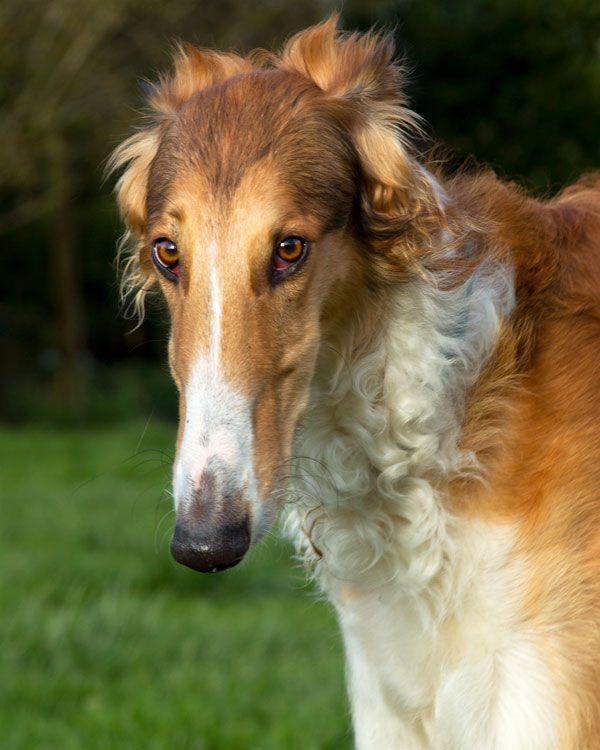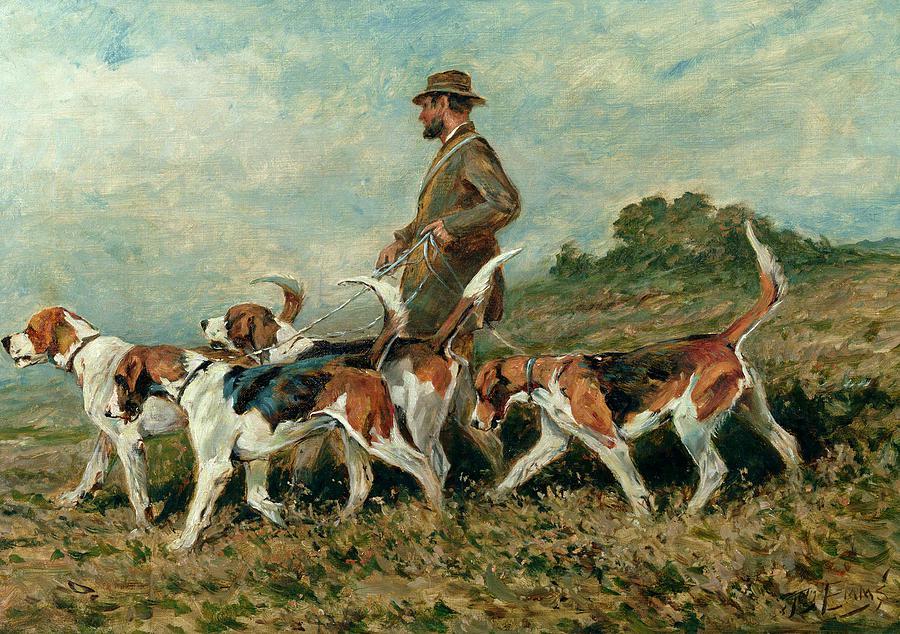The first image is the image on the left, the second image is the image on the right. Considering the images on both sides, is "There is at least one horse in the same image as a man." valid? Answer yes or no. No. 